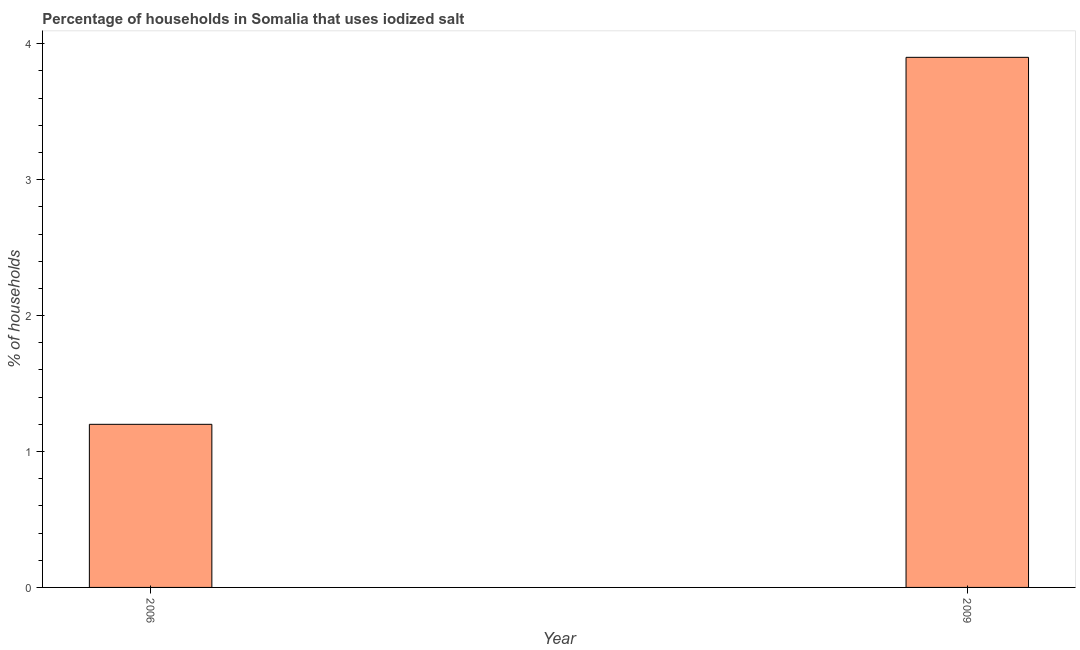Does the graph contain any zero values?
Provide a short and direct response. No. Does the graph contain grids?
Your answer should be compact. No. What is the title of the graph?
Provide a short and direct response. Percentage of households in Somalia that uses iodized salt. What is the label or title of the X-axis?
Offer a very short reply. Year. What is the label or title of the Y-axis?
Your answer should be very brief. % of households. What is the percentage of households where iodized salt is consumed in 2009?
Your answer should be compact. 3.9. In which year was the percentage of households where iodized salt is consumed maximum?
Offer a very short reply. 2009. What is the average percentage of households where iodized salt is consumed per year?
Provide a short and direct response. 2.55. What is the median percentage of households where iodized salt is consumed?
Offer a very short reply. 2.55. What is the ratio of the percentage of households where iodized salt is consumed in 2006 to that in 2009?
Keep it short and to the point. 0.31. Is the percentage of households where iodized salt is consumed in 2006 less than that in 2009?
Ensure brevity in your answer.  Yes. In how many years, is the percentage of households where iodized salt is consumed greater than the average percentage of households where iodized salt is consumed taken over all years?
Provide a short and direct response. 1. How many bars are there?
Offer a very short reply. 2. Are all the bars in the graph horizontal?
Offer a terse response. No. How many years are there in the graph?
Give a very brief answer. 2. Are the values on the major ticks of Y-axis written in scientific E-notation?
Give a very brief answer. No. What is the % of households of 2009?
Keep it short and to the point. 3.9. What is the difference between the % of households in 2006 and 2009?
Your answer should be compact. -2.7. What is the ratio of the % of households in 2006 to that in 2009?
Your answer should be compact. 0.31. 